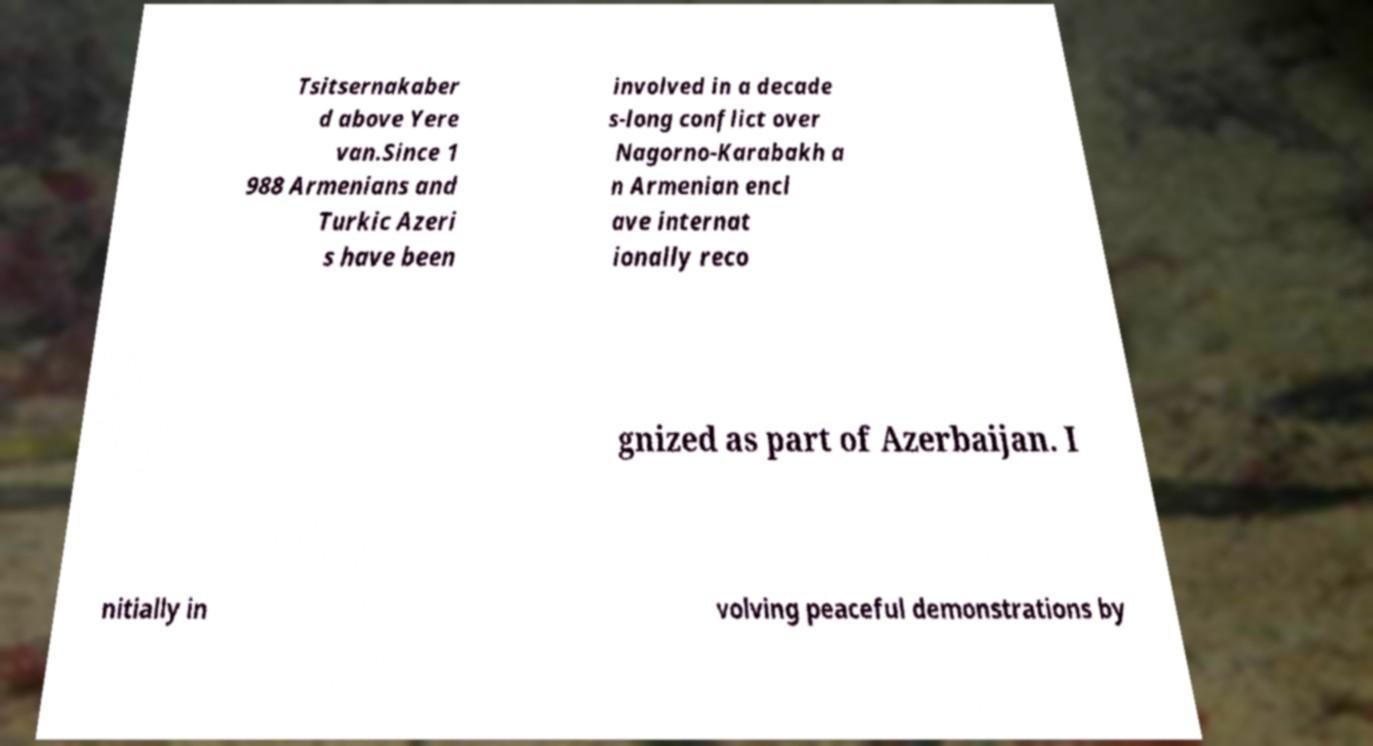I need the written content from this picture converted into text. Can you do that? Tsitsernakaber d above Yere van.Since 1 988 Armenians and Turkic Azeri s have been involved in a decade s-long conflict over Nagorno-Karabakh a n Armenian encl ave internat ionally reco gnized as part of Azerbaijan. I nitially in volving peaceful demonstrations by 